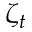Convert formula to latex. <formula><loc_0><loc_0><loc_500><loc_500>\zeta _ { t }</formula> 